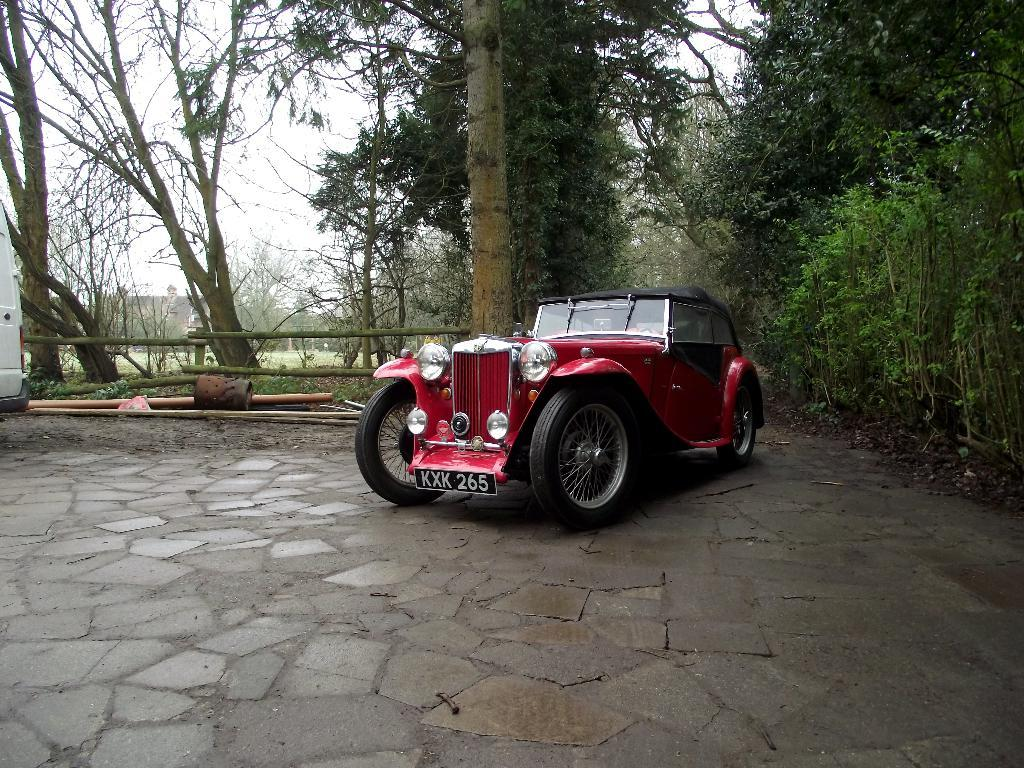What type of vehicles can be seen in the image? There are cars in the image. What can be seen in the distance behind the cars? There are trees and wooden barks in the background of the image. How many corks are scattered on the ground in the image? There are no corks visible in the image. 